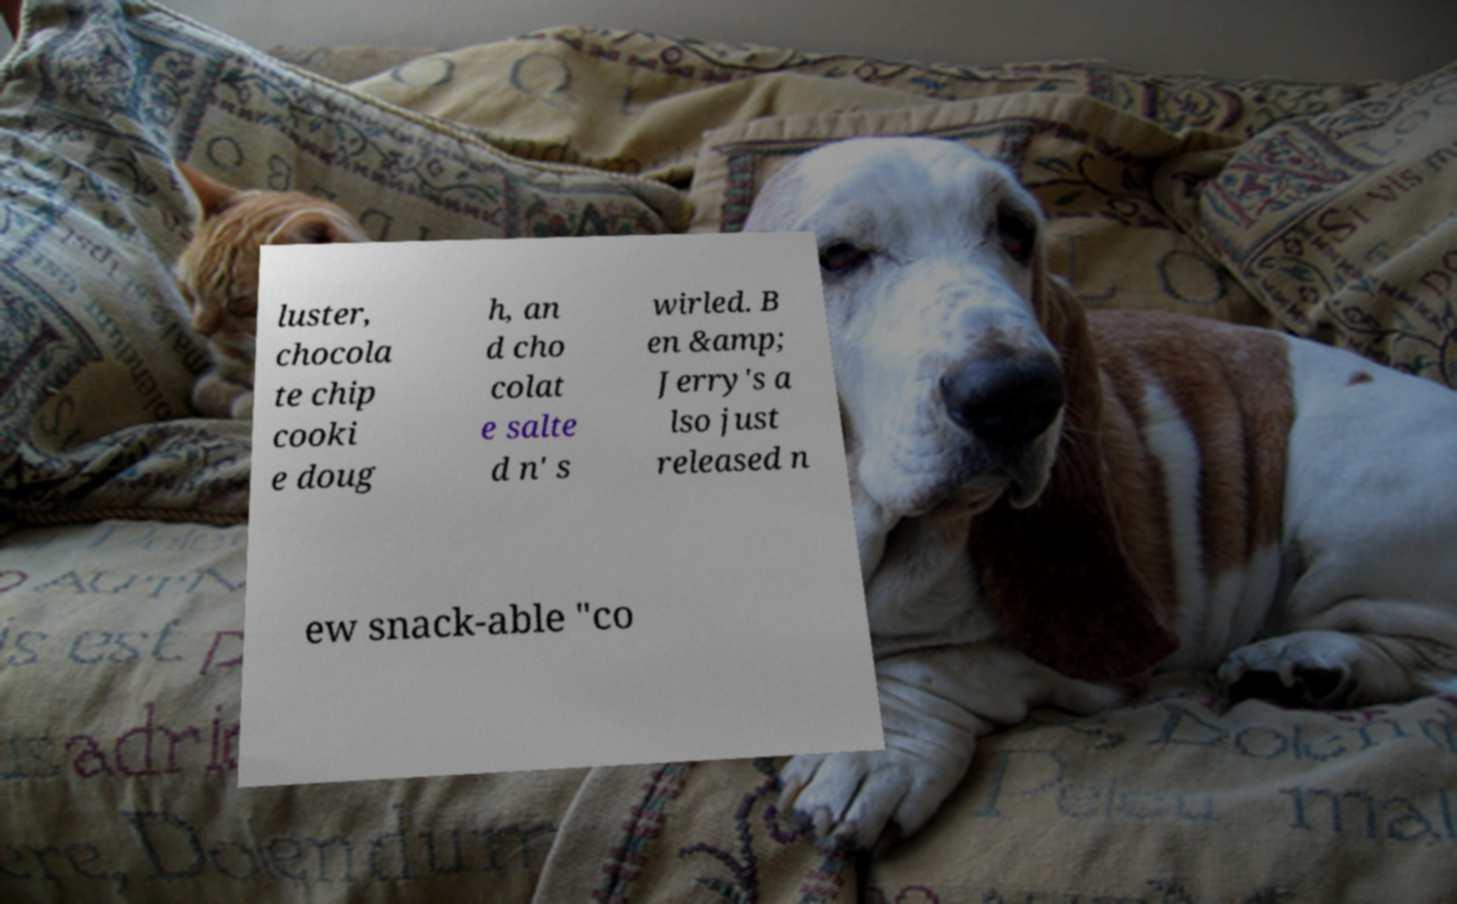What messages or text are displayed in this image? I need them in a readable, typed format. luster, chocola te chip cooki e doug h, an d cho colat e salte d n' s wirled. B en &amp; Jerry's a lso just released n ew snack-able "co 